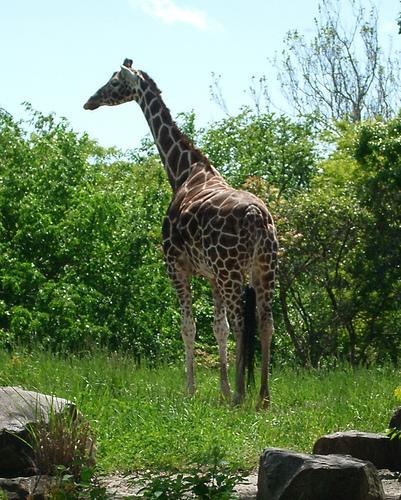Is the giraffe in a zoo?
Quick response, please. No. What does the giraffe eat?
Answer briefly. Leaves. Are these giraffes?
Answer briefly. Yes. Is this a baby giraffe?
Give a very brief answer. No. 